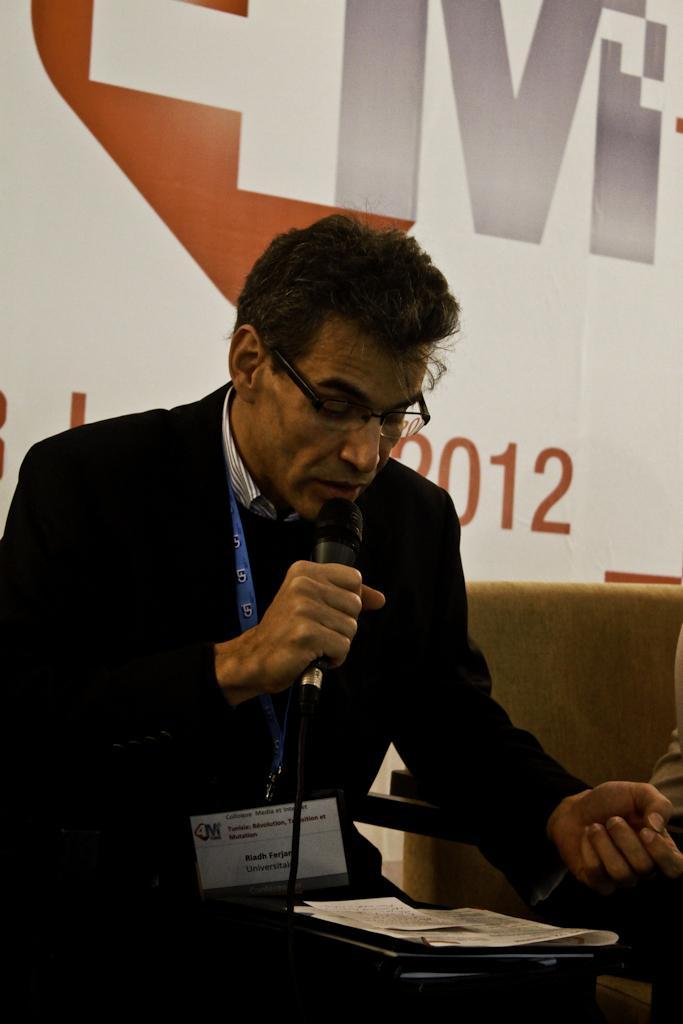Describe this image in one or two sentences. In this picture, we see a man with black blazer is holding microphone in his hand and talking on it. He is even wearing spectacles and ID card. In front of him, we see a table on which paper and file is placed. Beside him, we see a chair and behind him, we see a wall on which banner is placed on it. 